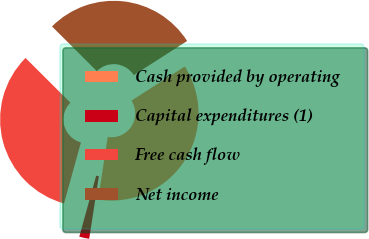Convert chart. <chart><loc_0><loc_0><loc_500><loc_500><pie_chart><fcel>Cash provided by operating<fcel>Capital expenditures (1)<fcel>Free cash flow<fcel>Net income<nl><fcel>36.5%<fcel>1.85%<fcel>33.18%<fcel>28.47%<nl></chart> 